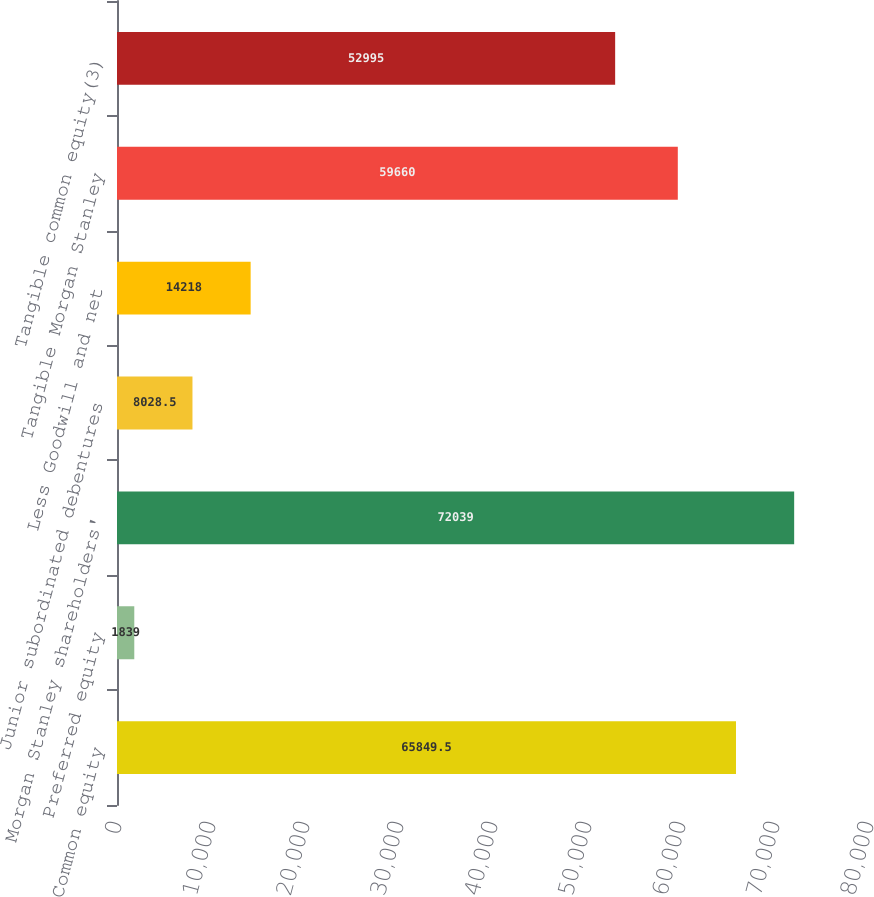Convert chart. <chart><loc_0><loc_0><loc_500><loc_500><bar_chart><fcel>Common equity<fcel>Preferred equity<fcel>Morgan Stanley shareholders'<fcel>Junior subordinated debentures<fcel>Less Goodwill and net<fcel>Tangible Morgan Stanley<fcel>Tangible common equity(3)<nl><fcel>65849.5<fcel>1839<fcel>72039<fcel>8028.5<fcel>14218<fcel>59660<fcel>52995<nl></chart> 